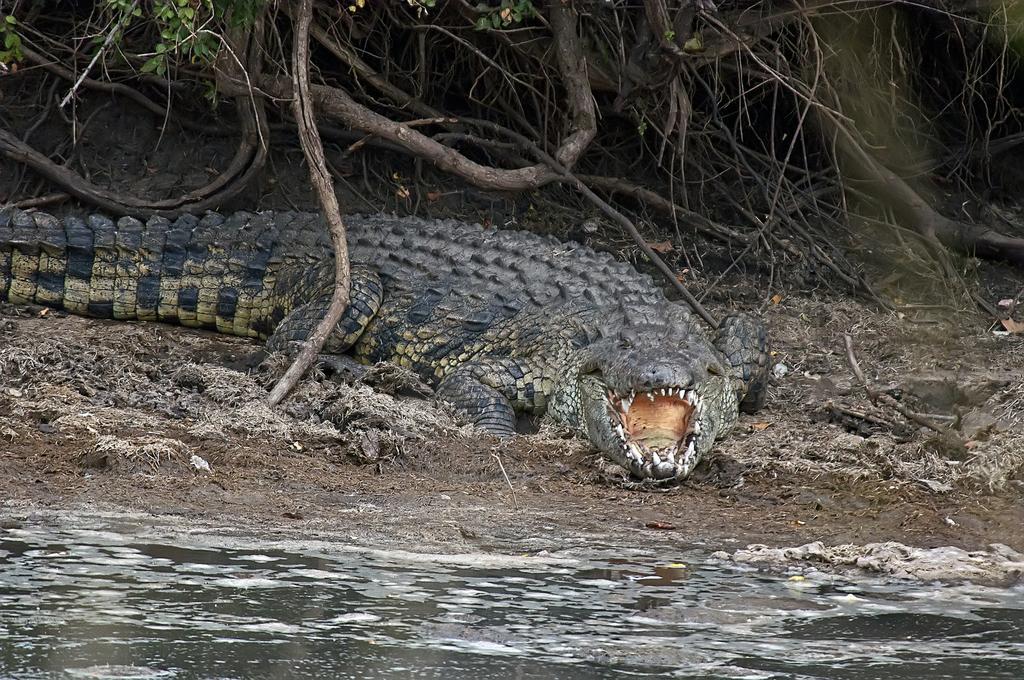Can you describe this image briefly? In the middle of the image there is a crocodile on the ground. At the bottom, I can see the water. In the background there are many sticks. 